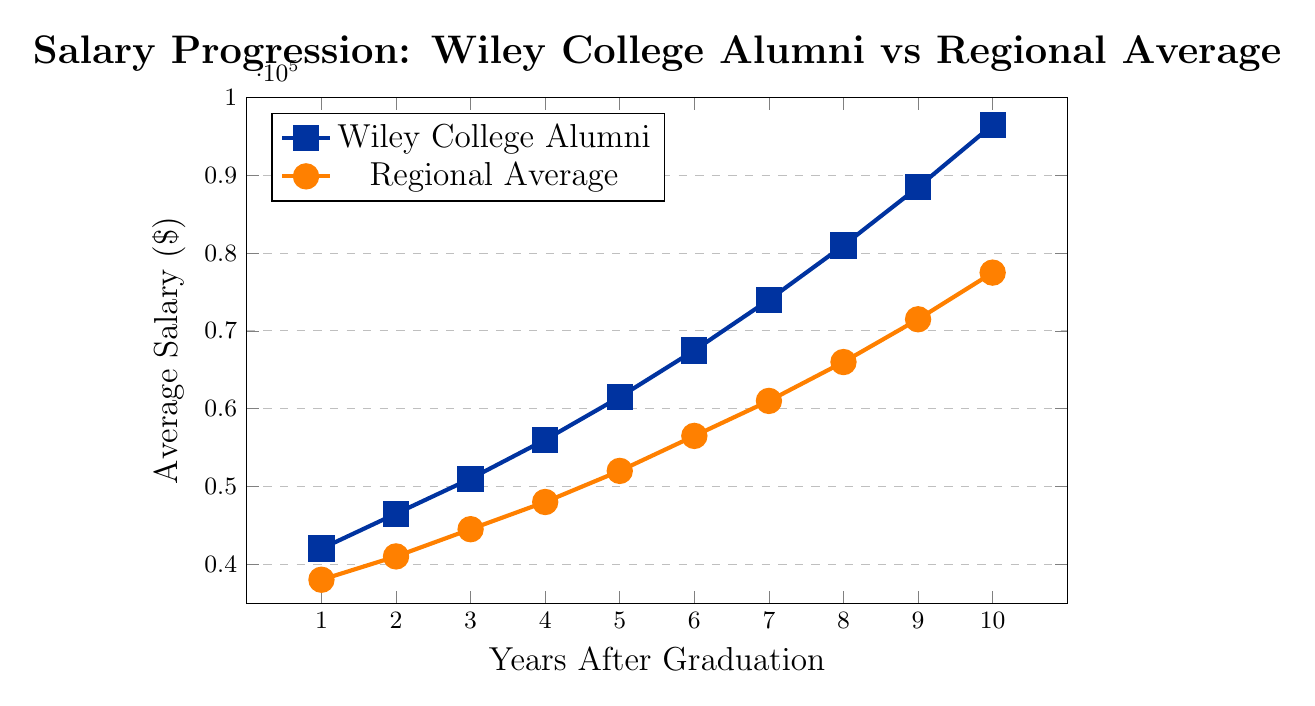What is the salary of Wiley College alumni in Year 5? To find the salary of Wiley College alumni in Year 5, look at the data point for Year 5 on the Wiley College Alumni line. The corresponding salary is $61,500.
Answer: $61,500 How much higher is the salary of Wiley College alumni compared to the regional average in Year 10? For Year 10, find the salaries for both Wiley College alumni and the regional average. The salaries are $96,500 and $77,500, respectively. Calculate the difference: $96,500 - $77,500 = $19,000.
Answer: $19,000 What is the trend of the salaries for both Wiley College alumni and the regional average from Year 1 to Year 10? Observe the lines representing Wiley College alumni and the regional average. Both lines show an increasing trend, indicating that salaries for both groups are rising over the 10 years.
Answer: Increasing At which year do Wiley College alumni first earn more than $70,000 on average? Check the data points for Wiley College alumni. The alumni first earn more than $70,000 in Year 7 with a salary of $74,000.
Answer: Year 7 Calculate the average salary for Wiley College alumni over the 10 years. Sum the salaries for Wiley College alumni from Year 1 to Year 10 and divide by the number of years: ($42,000 + $46,500 + $51,000 + $56,000 + $61,500 + $67,500 + $74,000 + $81,000 + $88,500 + $96,500) / 10 = $66,850.
Answer: $66,850 How many times during the 10 years is the salary of Wiley College alumni exactly $10,000 higher than the regional average? Subtract the regional average salary from the Wiley College alumni salary for each year and count how many times the difference is exactly $10,000. Only in Year 5 is the difference exactly $10,000 ($61,500 - $51,500).
Answer: Once Compare the growth rate between Wiley College alumni and the regional average from Year 1 to Year 2. Which group has a higher growth rate? Calculate the percentage increase for each group. For Wiley College alumni: ($46,500 - $42,000) / $42,000 * 100 ≈ 10.71%. For the regional average: ($41,000 - $38,000) / $38,000 * 100 ≈ 7.89%. Wiley College alumni have a higher growth rate.
Answer: Wiley College alumni Determine the percentage difference in salary between Wiley College alumni and the regional average in Year 8. Calculate the percentage difference [(Alumni - Regional) / Regional * 100]. For Year 8: ($81,000 - $66,000) / $66,000 * 100 ≈ 22.73%.
Answer: 22.73% What colors are used to represent Wiley College alumni and the regional average in the plot? The color used for Wiley College alumni is blue, and the color for the regional average is orange.
Answer: Blue for alumni, Orange for regional 